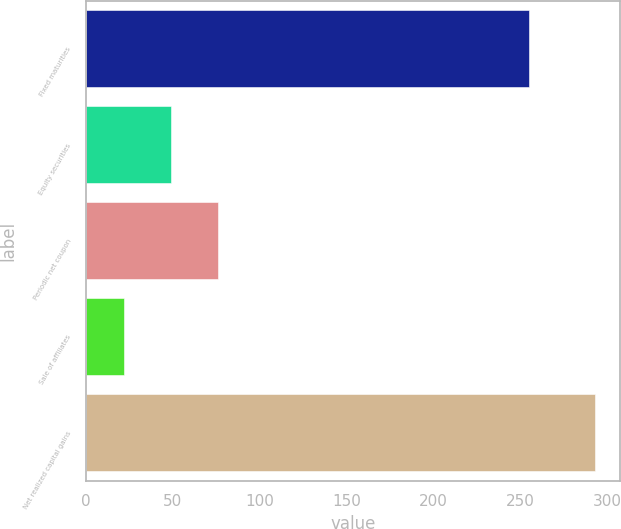Convert chart. <chart><loc_0><loc_0><loc_500><loc_500><bar_chart><fcel>Fixed maturities<fcel>Equity securities<fcel>Periodic net coupon<fcel>Sale of affiliates<fcel>Net realized capital gains<nl><fcel>255<fcel>49.1<fcel>76.2<fcel>22<fcel>293<nl></chart> 